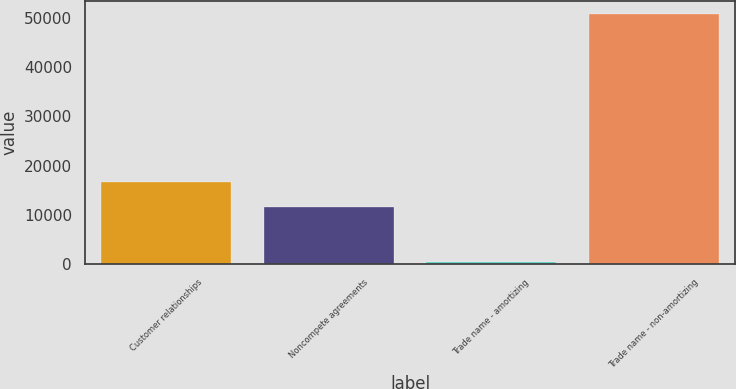Convert chart. <chart><loc_0><loc_0><loc_500><loc_500><bar_chart><fcel>Customer relationships<fcel>Noncompete agreements<fcel>Trade name - amortizing<fcel>Trade name - non-amortizing<nl><fcel>16664.5<fcel>11640<fcel>524<fcel>50769<nl></chart> 